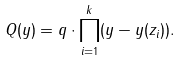<formula> <loc_0><loc_0><loc_500><loc_500>Q ( y ) = q \cdot \prod _ { i = 1 } ^ { k } ( y - y ( z _ { i } ) ) .</formula> 